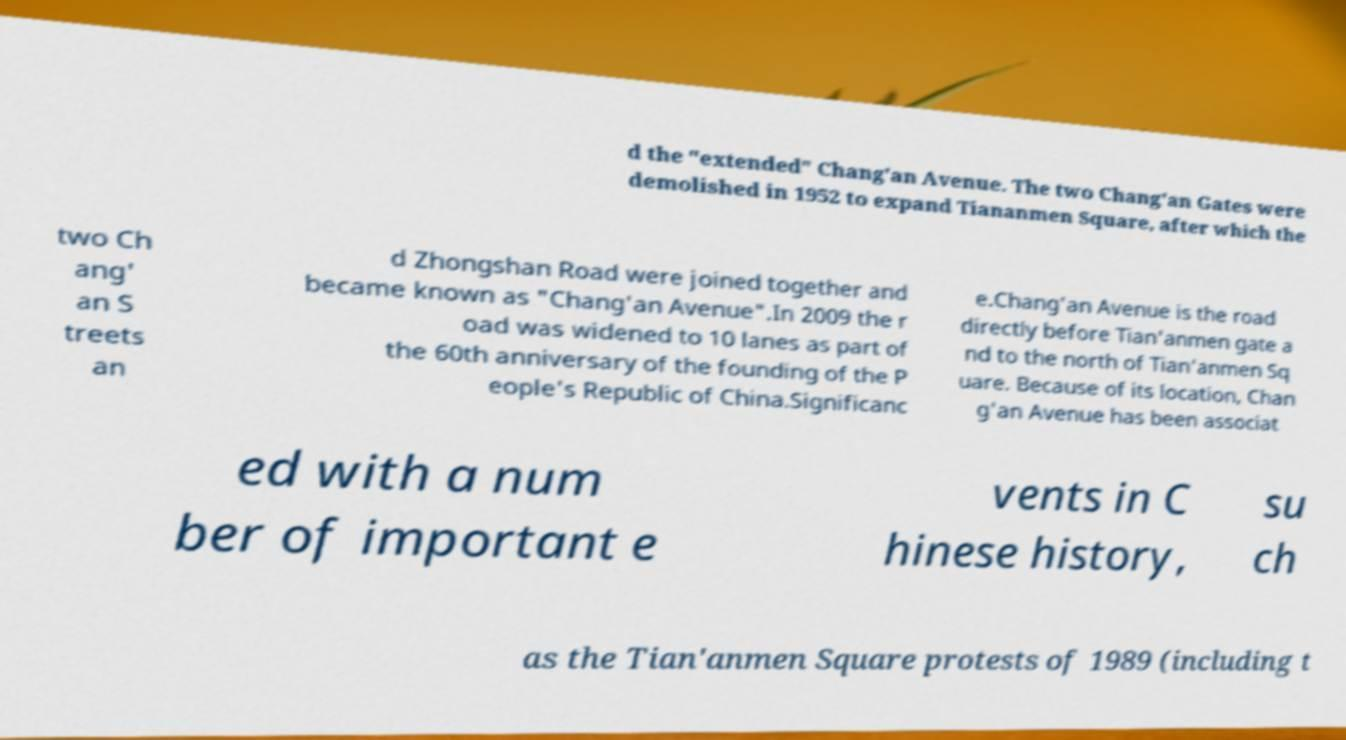Please read and relay the text visible in this image. What does it say? d the "extended" Chang'an Avenue. The two Chang'an Gates were demolished in 1952 to expand Tiananmen Square, after which the two Ch ang' an S treets an d Zhongshan Road were joined together and became known as "Chang'an Avenue".In 2009 the r oad was widened to 10 lanes as part of the 60th anniversary of the founding of the P eople's Republic of China.Significanc e.Chang'an Avenue is the road directly before Tian'anmen gate a nd to the north of Tian'anmen Sq uare. Because of its location, Chan g'an Avenue has been associat ed with a num ber of important e vents in C hinese history, su ch as the Tian'anmen Square protests of 1989 (including t 